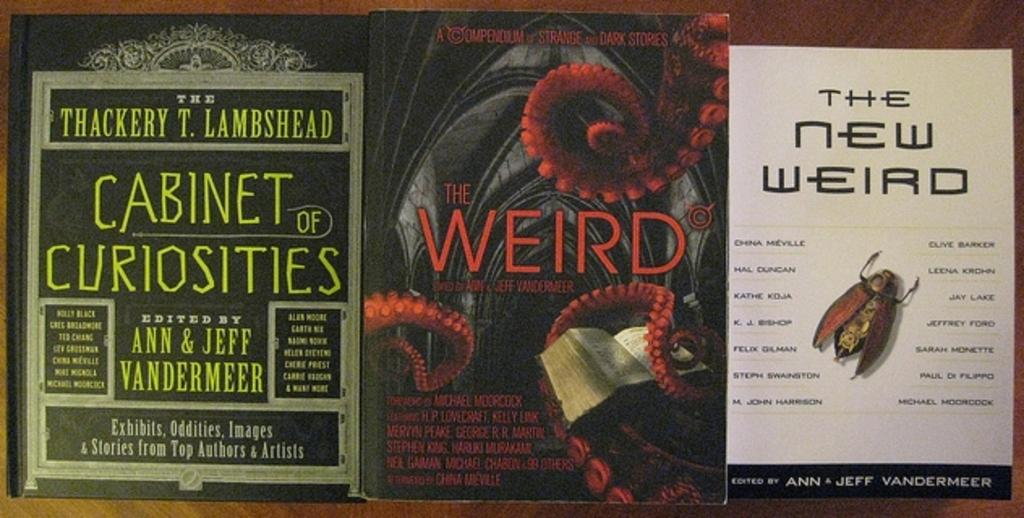Provide a one-sentence caption for the provided image. One of the books  is titled The New Weird. 